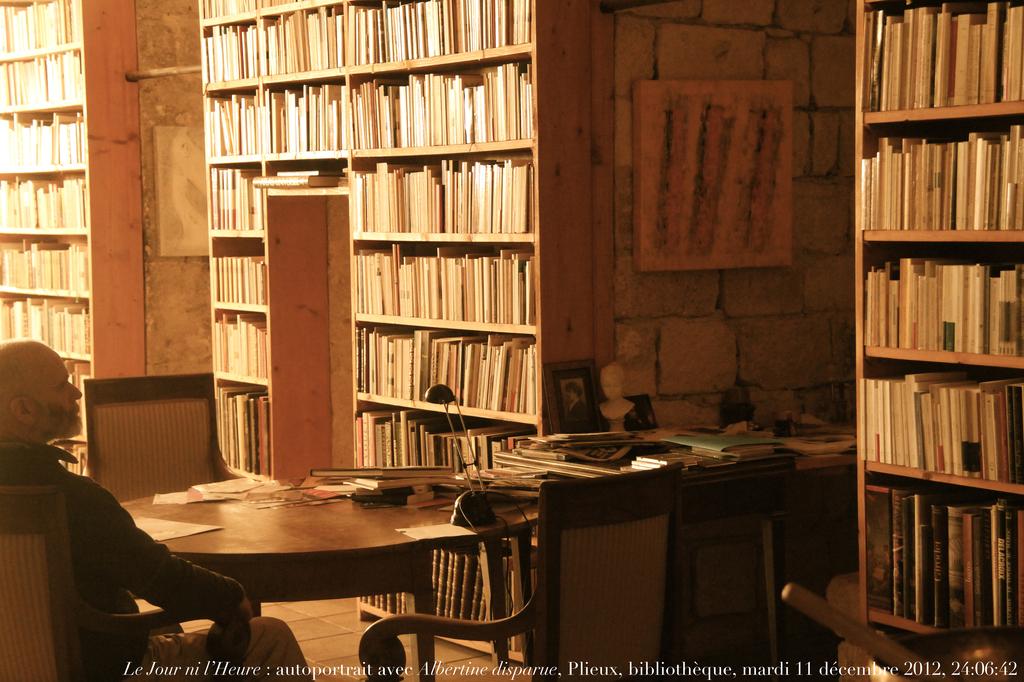What year is printed on the bottom?
Offer a terse response. 2012. 